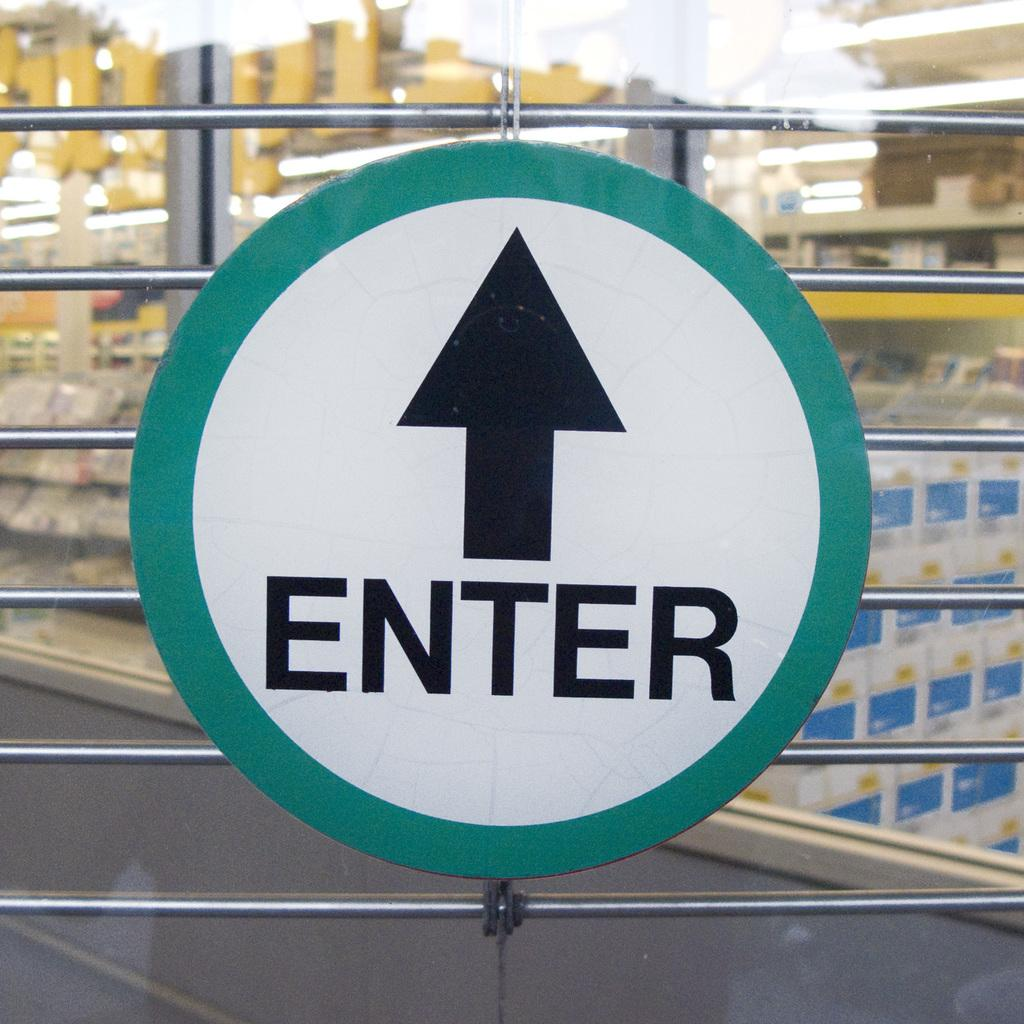<image>
Describe the image concisely. A greena nd black sign on a gate saying enter with an arrow pointing ahead. 